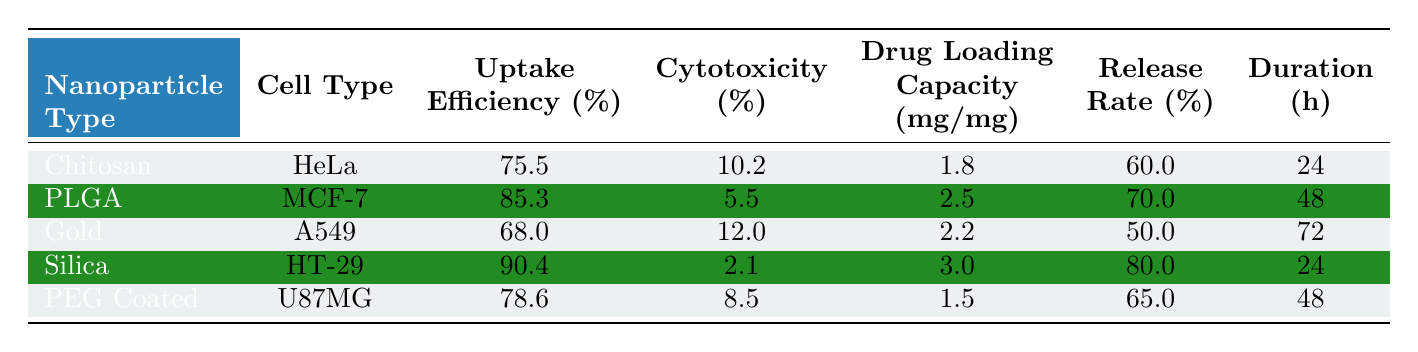What is the uptake efficiency percentage of Silica Nanoparticles in HT-29 Cells? The value for the uptake efficiency of Silica Nanoparticles in the HT-29 Cells row is directly stated as 90.4%.
Answer: 90.4% Which nanoparticle type has the highest drug loading capacity? Looking at the drug loading capacity column, Silica Nanoparticles in the HT-29 Cells have the highest value of 3.0 mg/mg.
Answer: Silica Nanoparticles Is the cytotoxicity percentage of PLGA Nanoparticles lower than that of Chitosan Nanoparticles? The cytotoxicity for PLGA Nanoparticles is 5.5%, while for Chitosan Nanoparticles it's 10.2%. Since 5.5% is less than 10.2%, the statement is true.
Answer: Yes What is the average uptake efficiency percentage of the nanoparticles listed? Summing the uptake efficiency percentages: (75.5 + 85.3 + 68.0 + 90.4 + 78.6) = 397.8, and dividing by the number of types (5) gives 397.8/5 = 79.56%.
Answer: 79.56% Which cell type has the lowest cytotoxicity percentage? Comparing the cytotoxicity percentages: HeLa Cells (10.2%), MCF-7 Cells (5.5%), A549 Cells (12.0%), HT-29 Cells (2.1%), and U87MG Cells (8.5%). HT-29 Cells at 2.1% has the lowest.
Answer: HT-29 Cells 